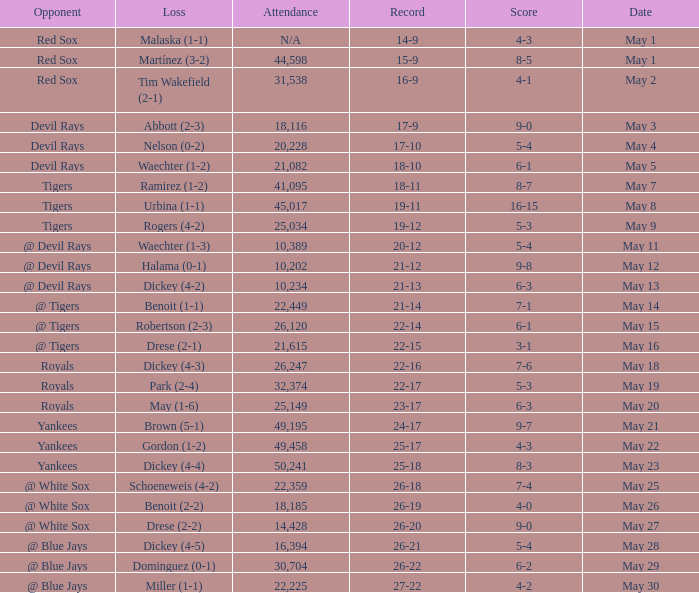What was the record at the game attended by 10,389? 20-12. 